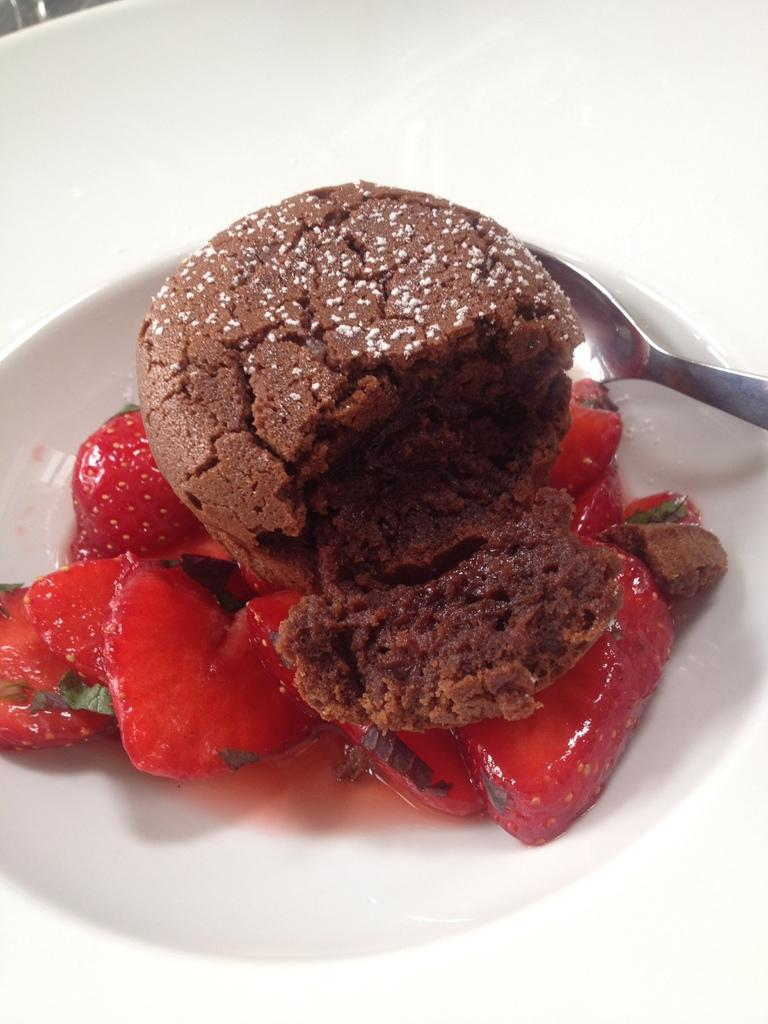What is in the bowl that is visible in the image? The bowl contains strawberries and a cake. What utensil is present in the image? There is a spoon in the image. What is the color of the bowl in the image? The bowl appears to be white in color. What language is the frog speaking in the image? There is no frog present in the image, so it is not possible to determine what language it might be speaking. 